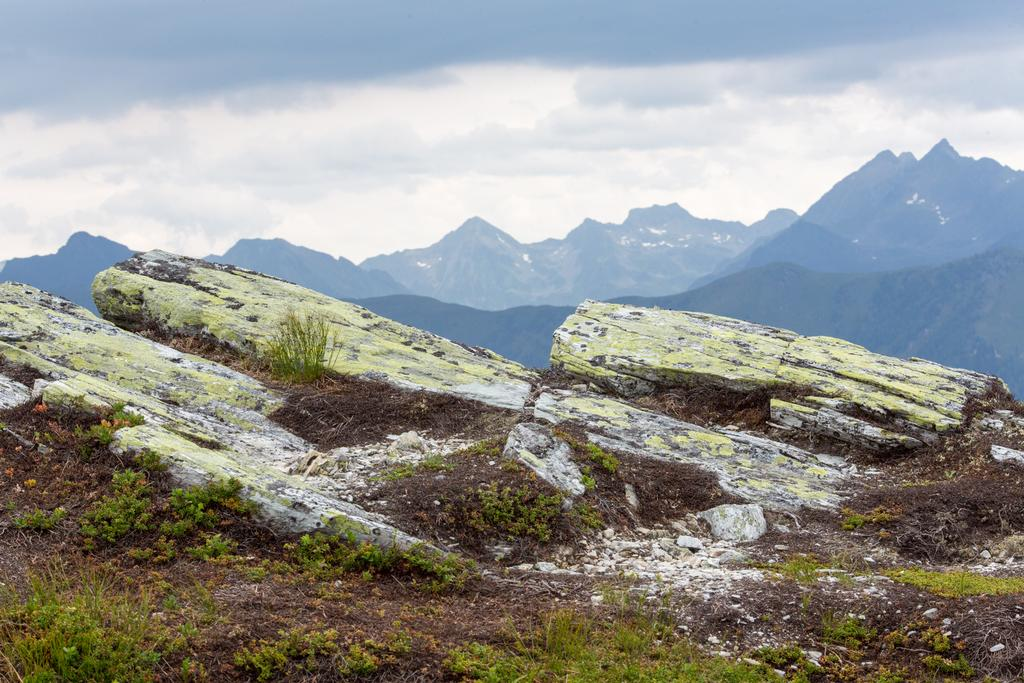What is the main feature in the middle of the image? There is a hill in the middle of the image. What can be seen at the top of the image? The sky is visible at the top of the image. What type of vegetation is present on the hill? There is grass on the hill at the bottom of the image. How many jokes are being told by the legs in the image? There are no legs or jokes present in the image. 